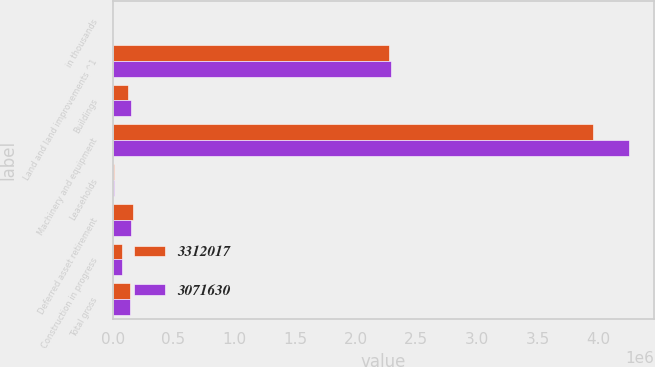Convert chart to OTSL. <chart><loc_0><loc_0><loc_500><loc_500><stacked_bar_chart><ecel><fcel>in thousands<fcel>Land and land improvements ^1<fcel>Buildings<fcel>Machinery and equipment<fcel>Leaseholds<fcel>Deferred asset retirement<fcel>Construction in progress<fcel>Total gross<nl><fcel>3.31202e+06<fcel>2014<fcel>2.27387e+06<fcel>126833<fcel>3.95242e+06<fcel>13451<fcel>163644<fcel>78617<fcel>138408<nl><fcel>3.07163e+06<fcel>2013<fcel>2.29509e+06<fcel>149982<fcel>4.2481e+06<fcel>11692<fcel>151973<fcel>76768<fcel>138408<nl></chart> 